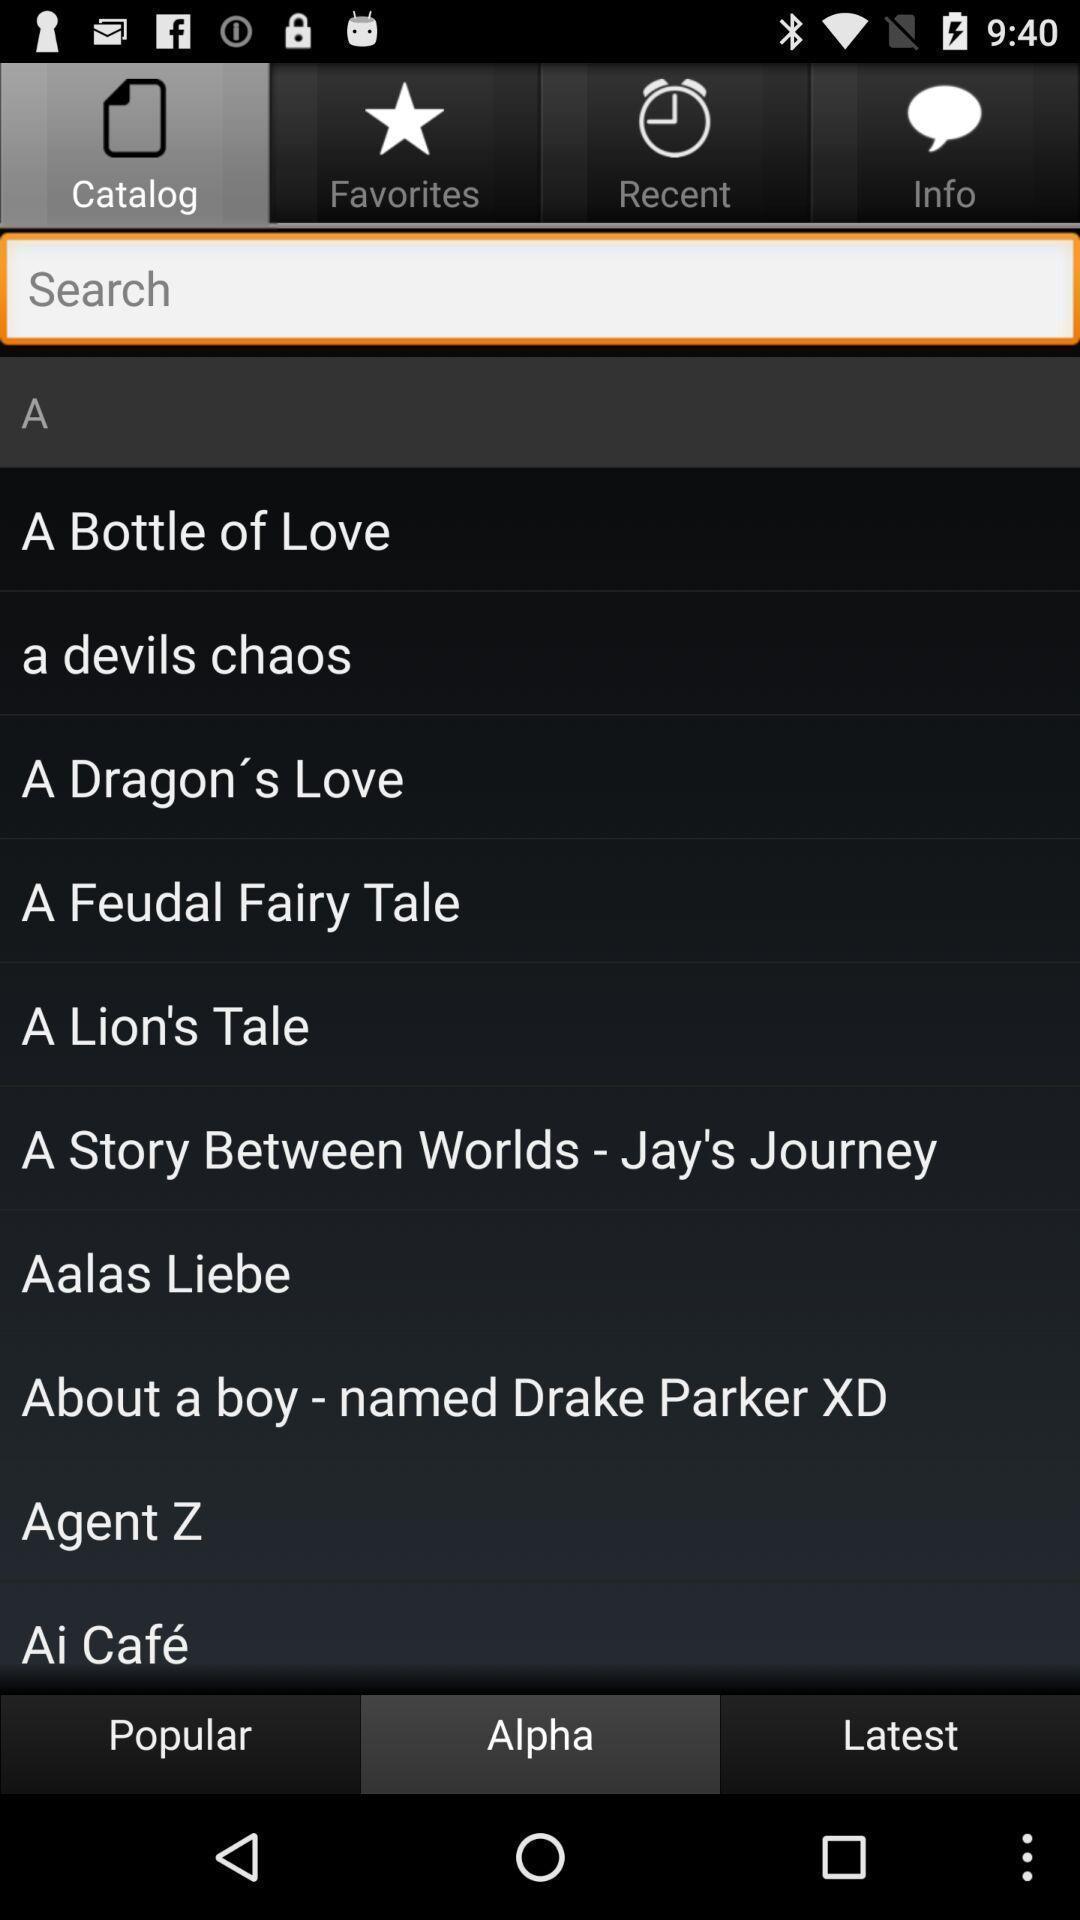Summarize the information in this screenshot. Search page for searching different stories. 